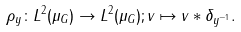Convert formula to latex. <formula><loc_0><loc_0><loc_500><loc_500>\rho _ { y } \colon L ^ { 2 } ( \mu _ { G } ) \rightarrow L ^ { 2 } ( \mu _ { G } ) ; v \mapsto v \ast \delta _ { y ^ { - 1 } } .</formula> 